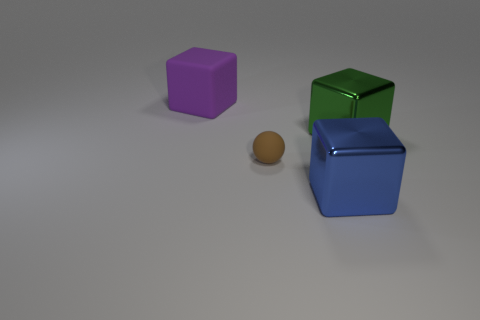What number of other objects are the same material as the big blue object?
Your response must be concise. 1. Is the number of big metal things less than the number of blue blocks?
Provide a succinct answer. No. Are the large purple object and the object to the right of the blue metal cube made of the same material?
Provide a short and direct response. No. There is a thing on the right side of the large blue thing; what is its shape?
Make the answer very short. Cube. Are there any other things that have the same color as the small object?
Offer a terse response. No. Are there fewer large purple things that are behind the large matte block than big metal balls?
Your answer should be compact. No. What number of other rubber objects have the same size as the purple rubber object?
Provide a short and direct response. 0. What shape is the shiny thing that is behind the big cube that is in front of the rubber thing that is in front of the purple matte thing?
Offer a very short reply. Cube. There is a block in front of the tiny rubber object; what is its color?
Offer a very short reply. Blue. What number of things are either cubes that are on the right side of the rubber block or big shiny objects in front of the brown matte sphere?
Your answer should be compact. 2. 